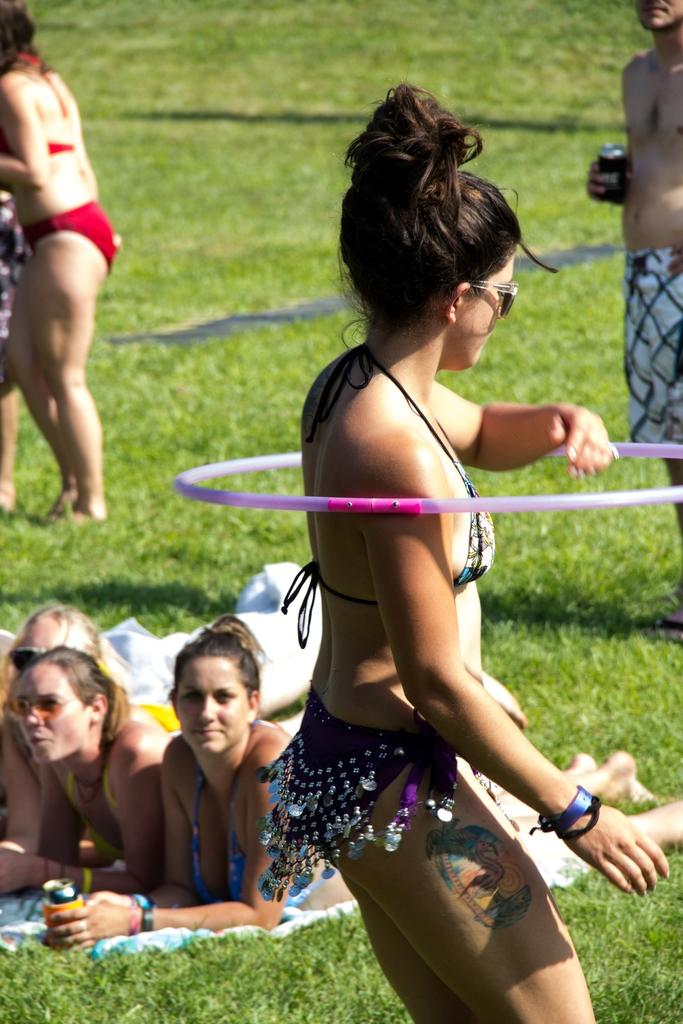What is the girl in the image doing? The girl is performing hula hoops in the image. Are there any other people present in the image? Yes, there are people standing behind the girl. What are the women in the image doing? The women are laying on the grass in the image. What type of jewel is the girl wearing in the image? There is no mention of a jewel in the image, so it cannot be determined if the girl is wearing one. 